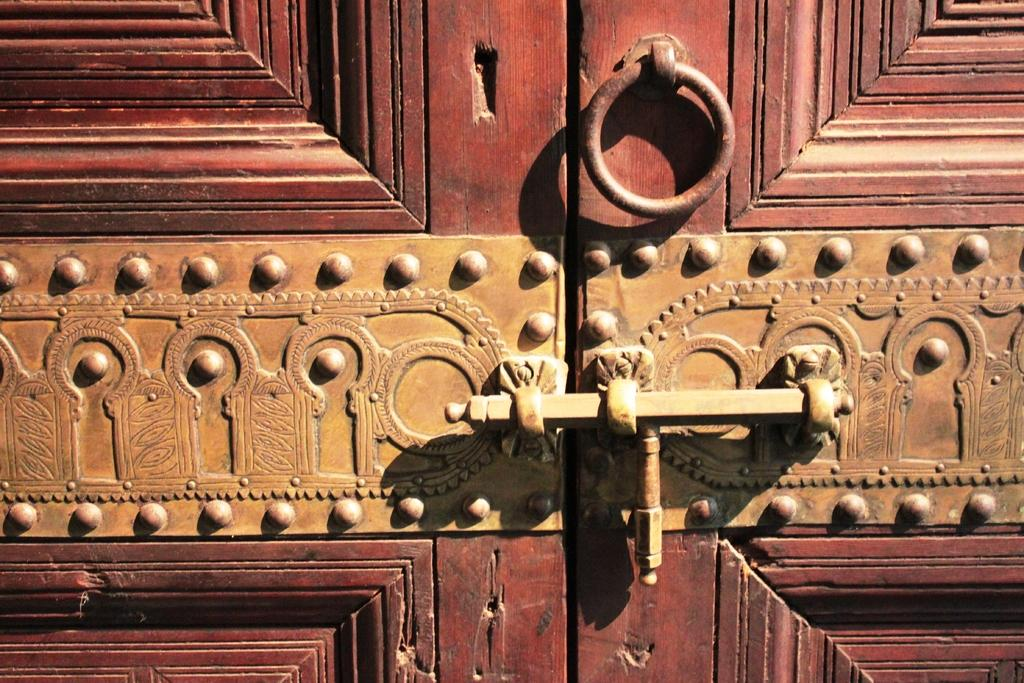What is a prominent feature in the image? There is a door in the image. What can be found on the door? The door has a knocker and a door belt. What type of club can be seen in the image? There is no club present in the image; it features a door with a knocker and a door belt. Is the door located in a cemetery in the image? There is no information about the location of the door in the image, but it is not depicted in a cemetery. 